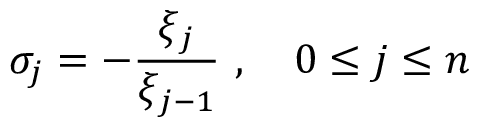Convert formula to latex. <formula><loc_0><loc_0><loc_500><loc_500>\sigma _ { j } = - \frac { \xi _ { j } } { \xi _ { j - 1 } } \ , \quad 0 \leq j \leq n</formula> 